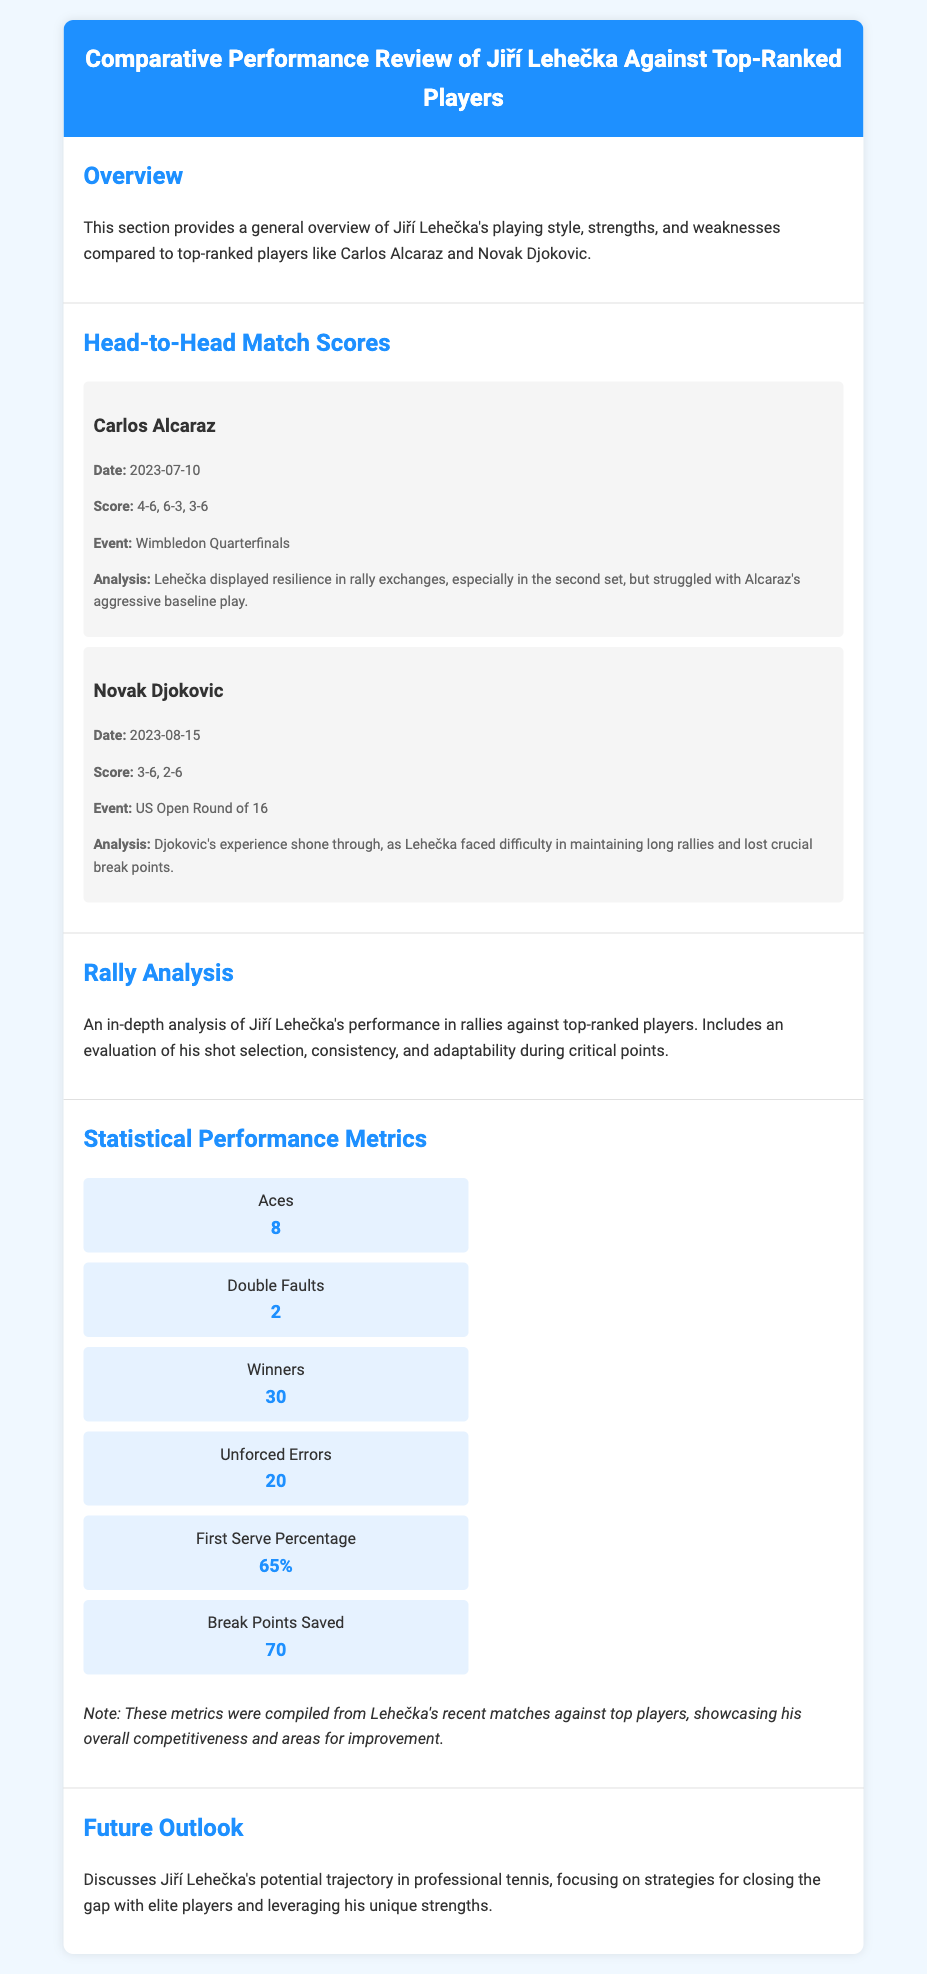What was the score in the match against Carlos Alcaraz? The score is mentioned in the match details section for the match against Carlos Alcaraz, listing the game scores as 4-6, 6-3, 3-6.
Answer: 4-6, 6-3, 3-6 What date did Jiří Lehečka play against Novak Djokovic? The date is specified in the match details for the match against Novak Djokovic, noted as 2023-08-15.
Answer: 2023-08-15 How many aces did Jiří Lehečka serve? This number is presented in the statistical performance metrics section listing a total of 8 aces.
Answer: 8 What was Jiří Lehečka's first serve percentage? The first serve percentage is part of the statistical performance metrics detailing it as 65%.
Answer: 65% In which event did Lehečka face Carlos Alcaraz? The event is noted in the match details section as the Wimbledon Quarterfinals.
Answer: Wimbledon Quarterfinals What was identified as a challenge for Lehečka against top-ranked players? Challenges are discussed in the analysis section of the match against Djokovic, highlighting difficulty in maintaining long rallies.
Answer: Maintaining long rallies What type of analysis is provided in the document? The document includes an in-depth analysis of rally performance, providing insights into shot selection and consistency.
Answer: Rally Analysis What are the total winners Jiří Lehečka achieved in recent matches? The total winners are specified under statistical performance metrics as 30.
Answer: 30 What does the future outlook section discuss? The future outlook section discusses strategies for Jiří Lehečka to close the gap with elite players and leverage strengths.
Answer: Strategies for closing the gap 